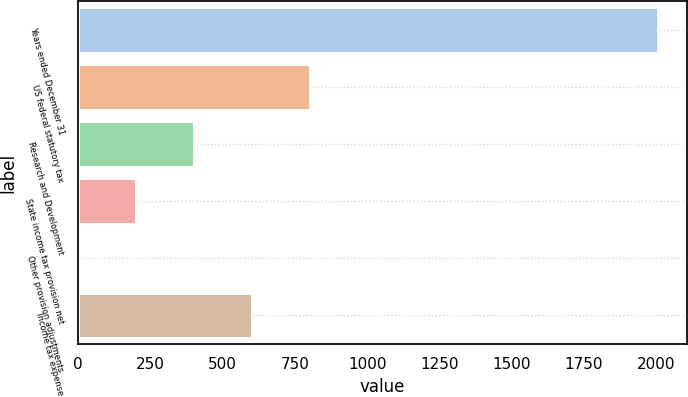Convert chart. <chart><loc_0><loc_0><loc_500><loc_500><bar_chart><fcel>Years ended December 31<fcel>US federal statutory tax<fcel>Research and Development<fcel>State income tax provision net<fcel>Other provision adjustments<fcel>Income tax expense<nl><fcel>2007<fcel>803.1<fcel>401.8<fcel>201.15<fcel>0.5<fcel>602.45<nl></chart> 